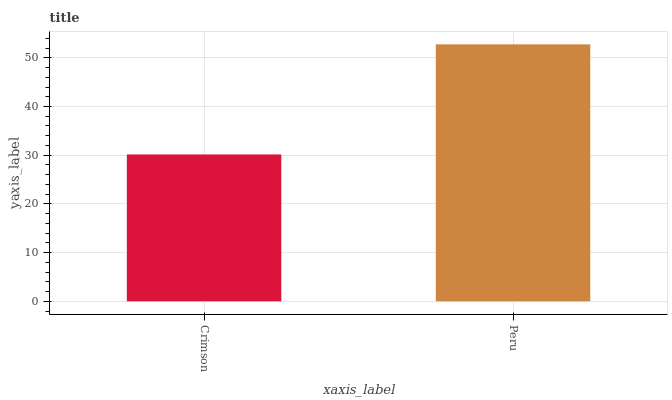Is Crimson the minimum?
Answer yes or no. Yes. Is Peru the maximum?
Answer yes or no. Yes. Is Peru the minimum?
Answer yes or no. No. Is Peru greater than Crimson?
Answer yes or no. Yes. Is Crimson less than Peru?
Answer yes or no. Yes. Is Crimson greater than Peru?
Answer yes or no. No. Is Peru less than Crimson?
Answer yes or no. No. Is Peru the high median?
Answer yes or no. Yes. Is Crimson the low median?
Answer yes or no. Yes. Is Crimson the high median?
Answer yes or no. No. Is Peru the low median?
Answer yes or no. No. 